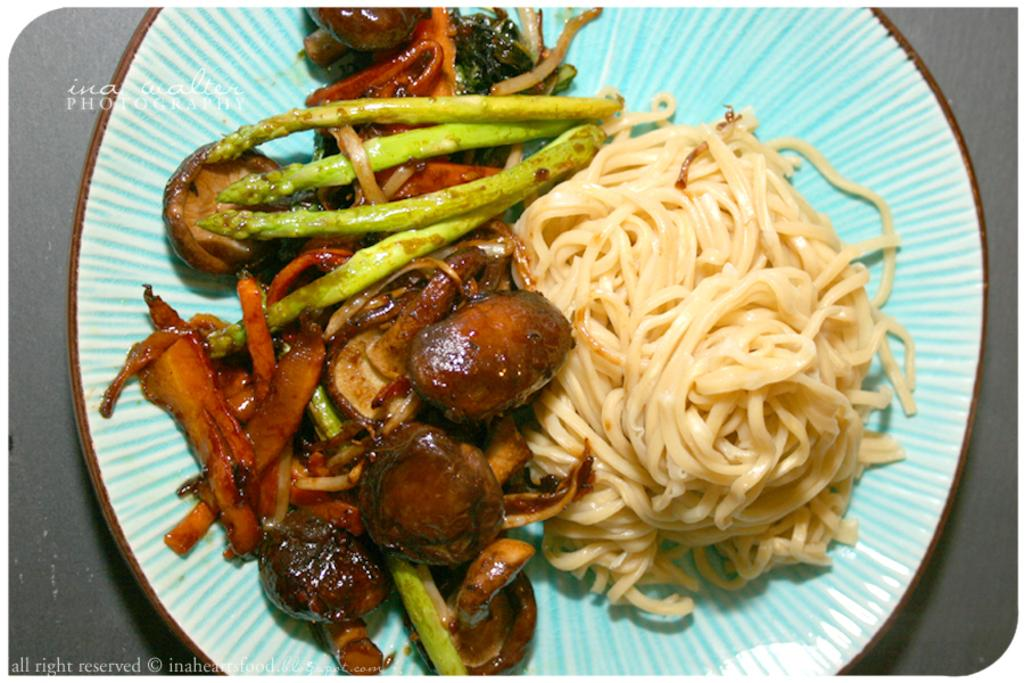What is present on the plate in the image? There are food items on the plate in the image. Can you describe the food items on the plate? Unfortunately, the provided facts do not specify the type of food items on the plate. What type of drink is being held by the hands in the image? There are no hands or drinks present in the image; it only features a plate with food items. Is there a branch visible in the image? There is no branch present in the image. 